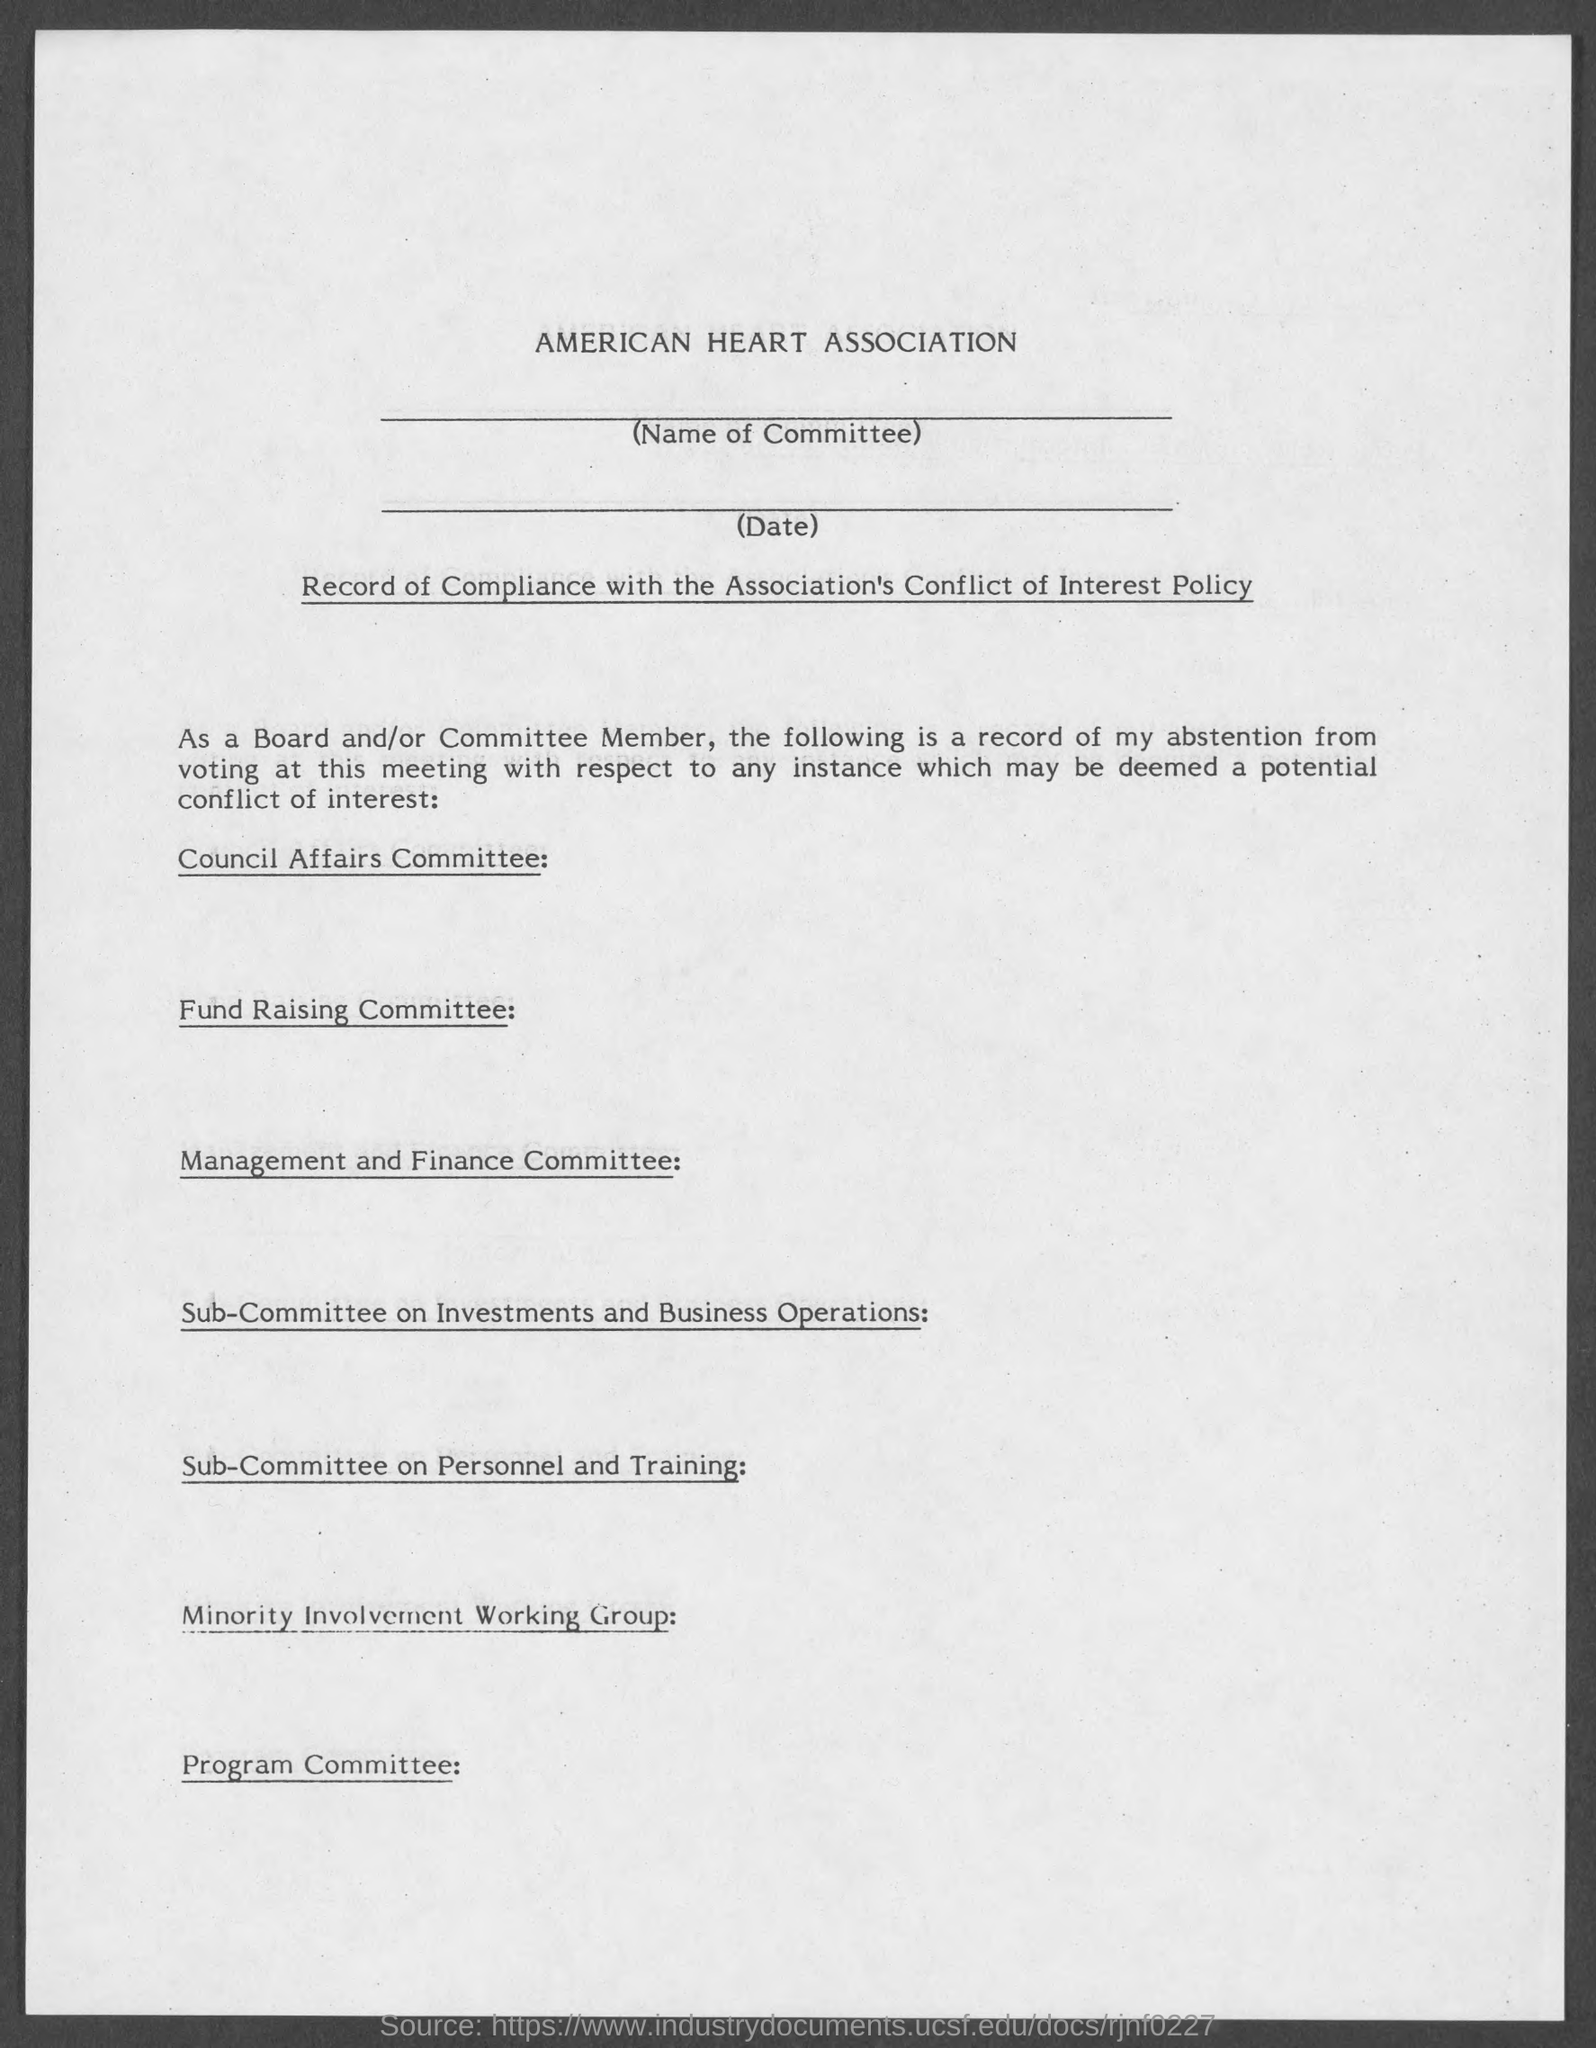Give some essential details in this illustration. The name of the association is the American Heart Association. 